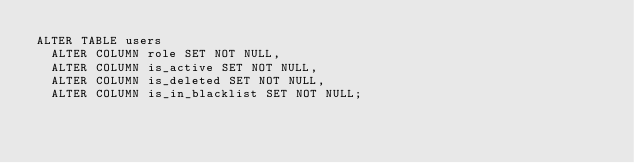Convert code to text. <code><loc_0><loc_0><loc_500><loc_500><_SQL_>ALTER TABLE users
  ALTER COLUMN role SET NOT NULL,
  ALTER COLUMN is_active SET NOT NULL,
  ALTER COLUMN is_deleted SET NOT NULL,
  ALTER COLUMN is_in_blacklist SET NOT NULL;
</code> 